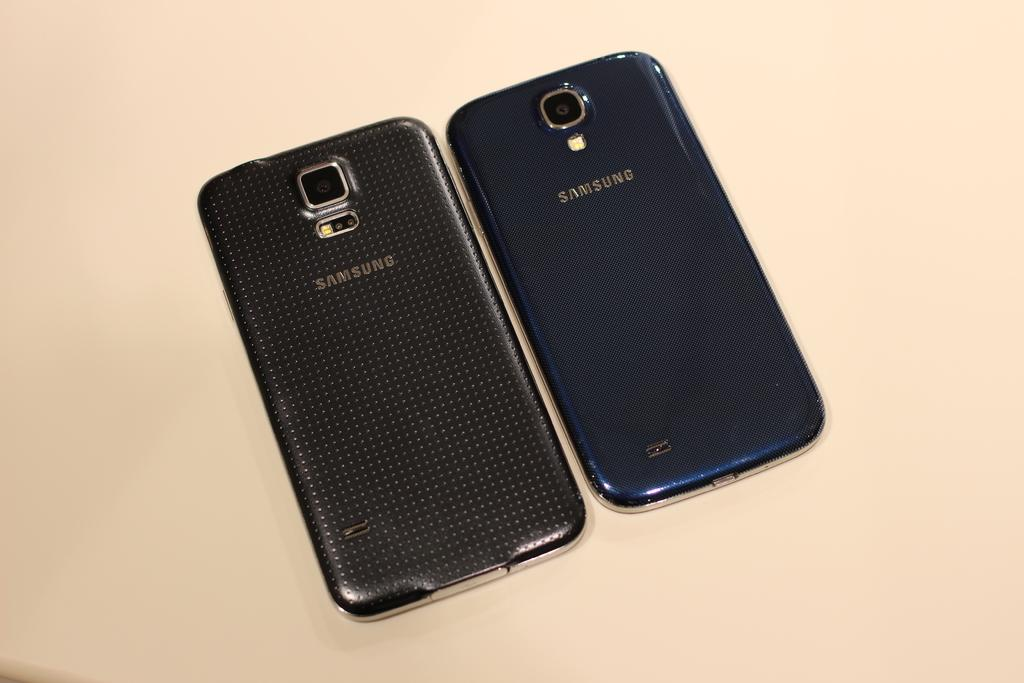<image>
Share a concise interpretation of the image provided. Two Samsung phones lie next to each other on a pale surface. 